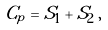<formula> <loc_0><loc_0><loc_500><loc_500>C _ { p } = S _ { 1 } + S _ { 2 } \, ,</formula> 